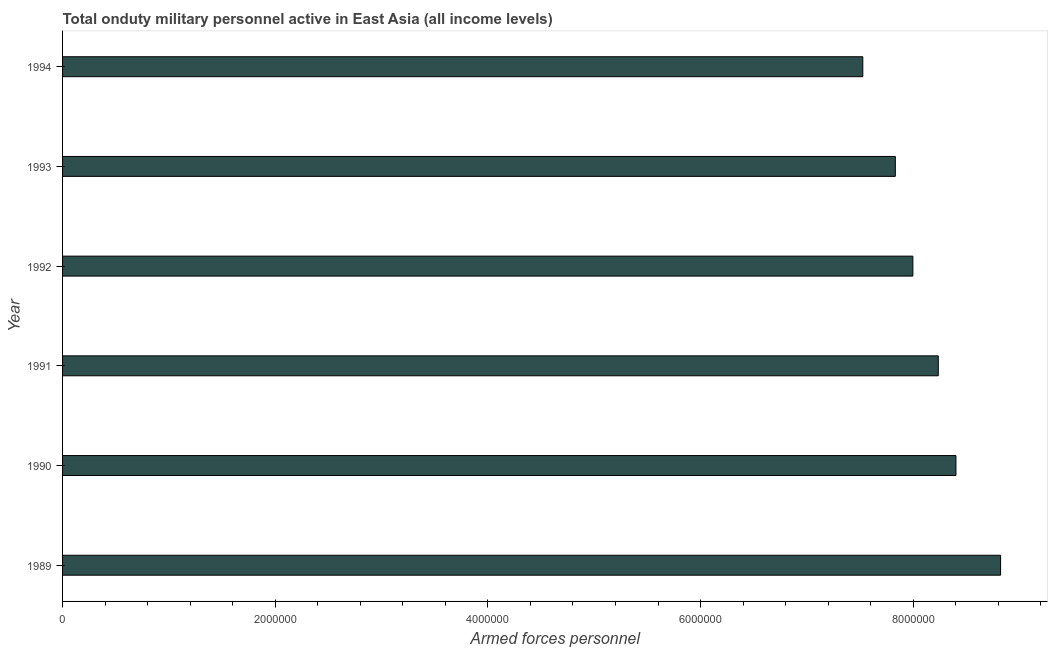Does the graph contain any zero values?
Your answer should be compact. No. Does the graph contain grids?
Your response must be concise. No. What is the title of the graph?
Your answer should be very brief. Total onduty military personnel active in East Asia (all income levels). What is the label or title of the X-axis?
Give a very brief answer. Armed forces personnel. What is the label or title of the Y-axis?
Provide a short and direct response. Year. What is the number of armed forces personnel in 1994?
Offer a terse response. 7.53e+06. Across all years, what is the maximum number of armed forces personnel?
Give a very brief answer. 8.82e+06. Across all years, what is the minimum number of armed forces personnel?
Provide a short and direct response. 7.53e+06. In which year was the number of armed forces personnel minimum?
Your answer should be very brief. 1994. What is the sum of the number of armed forces personnel?
Keep it short and to the point. 4.88e+07. What is the difference between the number of armed forces personnel in 1989 and 1993?
Give a very brief answer. 9.90e+05. What is the average number of armed forces personnel per year?
Your answer should be compact. 8.14e+06. What is the median number of armed forces personnel?
Make the answer very short. 8.12e+06. What is the ratio of the number of armed forces personnel in 1989 to that in 1992?
Ensure brevity in your answer.  1.1. Is the number of armed forces personnel in 1990 less than that in 1994?
Your response must be concise. No. Is the difference between the number of armed forces personnel in 1991 and 1993 greater than the difference between any two years?
Give a very brief answer. No. What is the difference between the highest and the second highest number of armed forces personnel?
Your answer should be compact. 4.20e+05. What is the difference between the highest and the lowest number of armed forces personnel?
Provide a short and direct response. 1.30e+06. In how many years, is the number of armed forces personnel greater than the average number of armed forces personnel taken over all years?
Ensure brevity in your answer.  3. How many years are there in the graph?
Your answer should be very brief. 6. What is the Armed forces personnel in 1989?
Give a very brief answer. 8.82e+06. What is the Armed forces personnel in 1990?
Provide a short and direct response. 8.40e+06. What is the Armed forces personnel in 1991?
Your response must be concise. 8.24e+06. What is the Armed forces personnel in 1992?
Keep it short and to the point. 8.00e+06. What is the Armed forces personnel in 1993?
Give a very brief answer. 7.83e+06. What is the Armed forces personnel in 1994?
Ensure brevity in your answer.  7.53e+06. What is the difference between the Armed forces personnel in 1989 and 1991?
Your response must be concise. 5.86e+05. What is the difference between the Armed forces personnel in 1989 and 1992?
Your answer should be compact. 8.25e+05. What is the difference between the Armed forces personnel in 1989 and 1993?
Your answer should be compact. 9.90e+05. What is the difference between the Armed forces personnel in 1989 and 1994?
Provide a succinct answer. 1.30e+06. What is the difference between the Armed forces personnel in 1990 and 1991?
Offer a terse response. 1.66e+05. What is the difference between the Armed forces personnel in 1990 and 1992?
Ensure brevity in your answer.  4.05e+05. What is the difference between the Armed forces personnel in 1990 and 1993?
Provide a succinct answer. 5.70e+05. What is the difference between the Armed forces personnel in 1990 and 1994?
Your answer should be very brief. 8.76e+05. What is the difference between the Armed forces personnel in 1991 and 1992?
Give a very brief answer. 2.39e+05. What is the difference between the Armed forces personnel in 1991 and 1993?
Make the answer very short. 4.04e+05. What is the difference between the Armed forces personnel in 1991 and 1994?
Offer a terse response. 7.10e+05. What is the difference between the Armed forces personnel in 1992 and 1993?
Offer a terse response. 1.65e+05. What is the difference between the Armed forces personnel in 1992 and 1994?
Your response must be concise. 4.71e+05. What is the difference between the Armed forces personnel in 1993 and 1994?
Your response must be concise. 3.06e+05. What is the ratio of the Armed forces personnel in 1989 to that in 1991?
Offer a very short reply. 1.07. What is the ratio of the Armed forces personnel in 1989 to that in 1992?
Give a very brief answer. 1.1. What is the ratio of the Armed forces personnel in 1989 to that in 1993?
Ensure brevity in your answer.  1.13. What is the ratio of the Armed forces personnel in 1989 to that in 1994?
Ensure brevity in your answer.  1.17. What is the ratio of the Armed forces personnel in 1990 to that in 1992?
Your response must be concise. 1.05. What is the ratio of the Armed forces personnel in 1990 to that in 1993?
Your answer should be compact. 1.07. What is the ratio of the Armed forces personnel in 1990 to that in 1994?
Provide a short and direct response. 1.12. What is the ratio of the Armed forces personnel in 1991 to that in 1992?
Your answer should be very brief. 1.03. What is the ratio of the Armed forces personnel in 1991 to that in 1993?
Offer a very short reply. 1.05. What is the ratio of the Armed forces personnel in 1991 to that in 1994?
Make the answer very short. 1.09. What is the ratio of the Armed forces personnel in 1992 to that in 1994?
Ensure brevity in your answer.  1.06. What is the ratio of the Armed forces personnel in 1993 to that in 1994?
Provide a short and direct response. 1.04. 